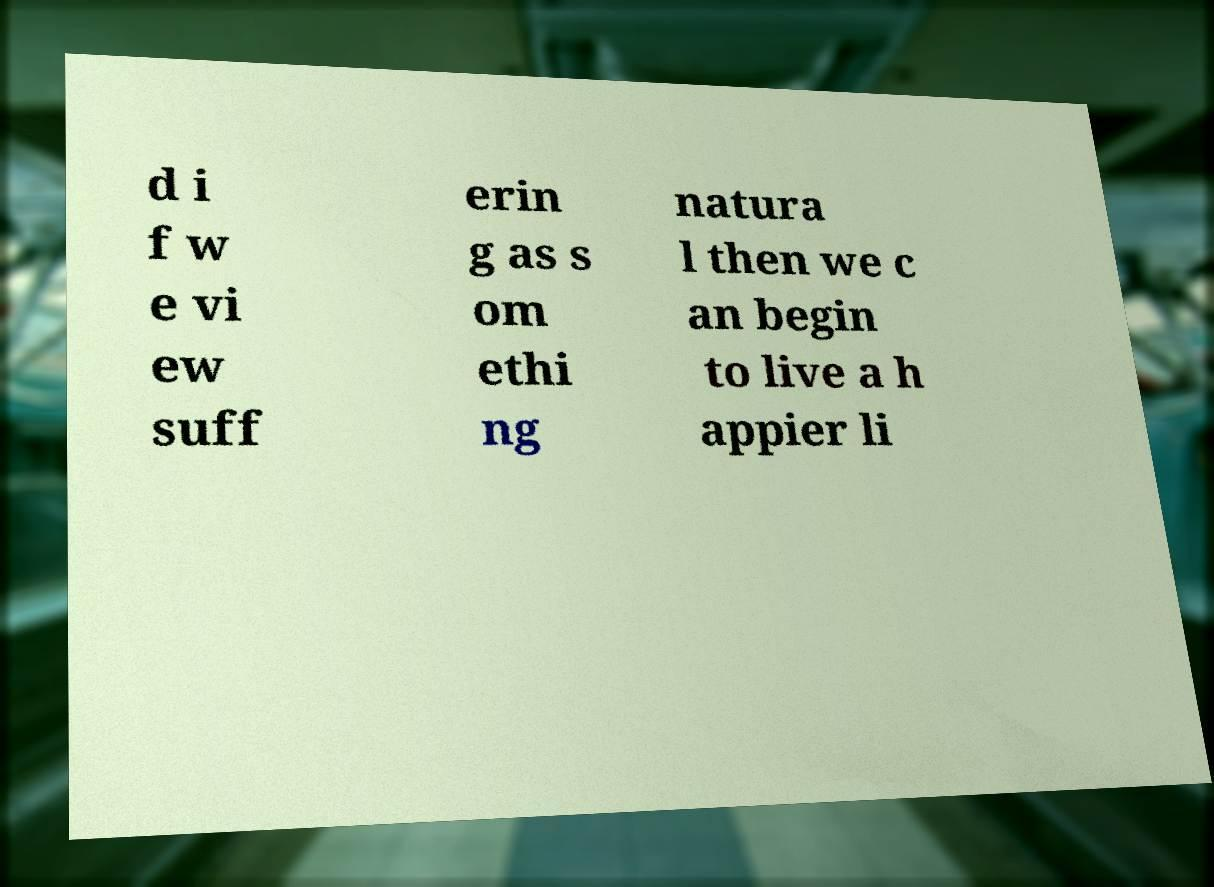Can you accurately transcribe the text from the provided image for me? d i f w e vi ew suff erin g as s om ethi ng natura l then we c an begin to live a h appier li 